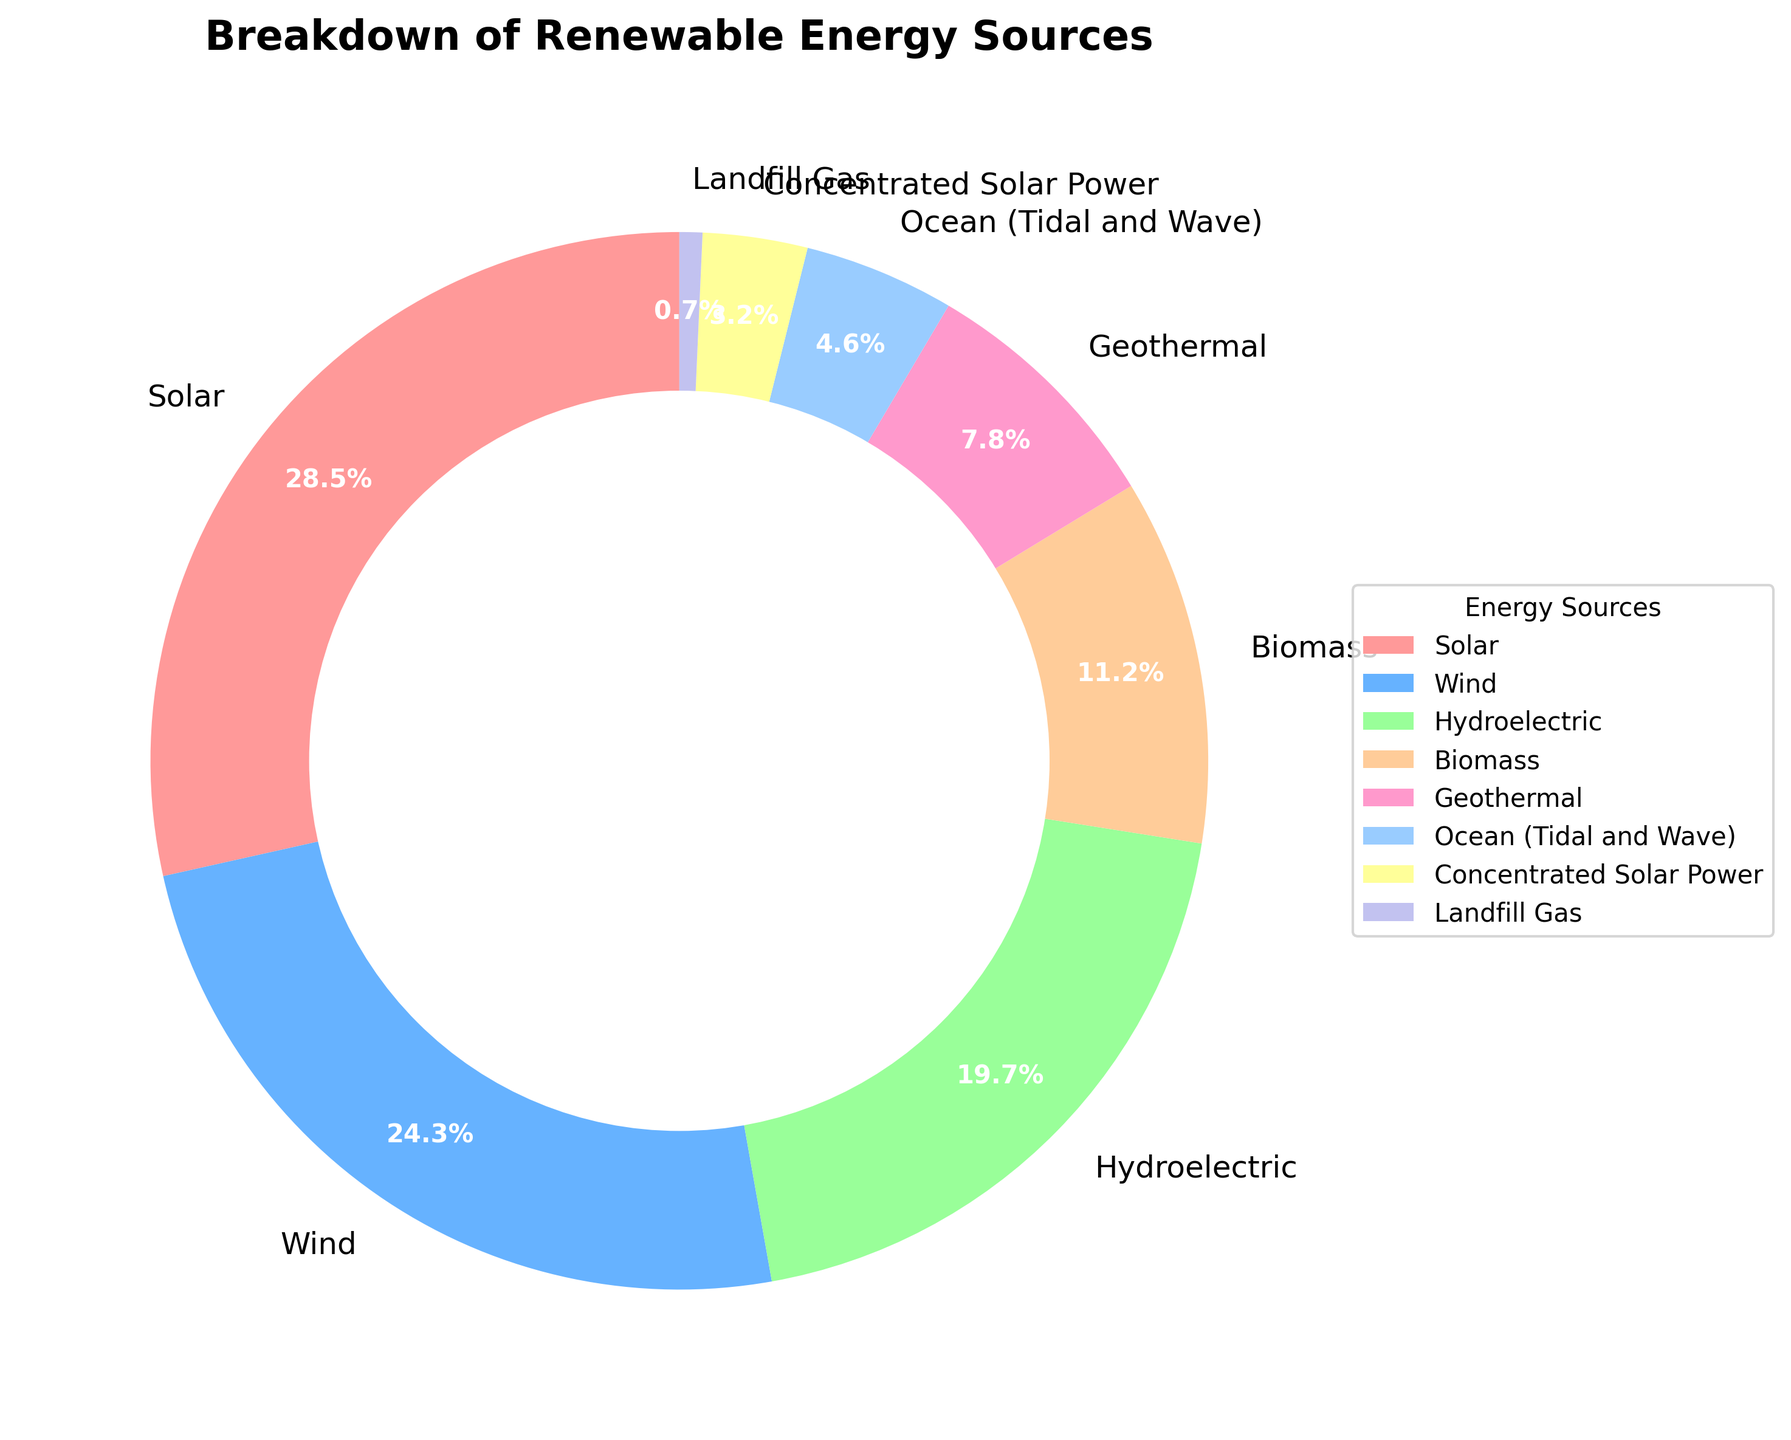Which energy source constitutes the largest portion of renewable energy production? The largest portion is identified by the section on the pie chart with the highest percentage value. Solar energy is marked with 28.5%, which is the highest.
Answer: Solar What is the combined percentage of wind, hydroelectric, and biomass energy sources? Adding the percentages for wind (24.3%), hydroelectric (19.7%), and biomass (11.2%) gives us 24.3 + 19.7 + 11.2 = 55.2%.
Answer: 55.2% Is the percentage of geothermal energy greater than the combined percentage of ocean (tidal and wave) and landfill gas? The percentage of geothermal energy is 7.8%. The combined percentage of ocean (4.6%) and landfill gas (0.7%) is 4.6 + 0.7 = 5.3%. Since 7.8% > 5.3%, geothermal is greater.
Answer: Yes Which energy source has the smallest contribution to the total energy production? The smallest portion is identified by the section on the pie chart with the lowest percentage value. Landfill Gas is marked with 0.7%, which is the smallest.
Answer: Landfill Gas What is the difference in percentage between solar and wind energy production? The difference is calculated as subtracting the percentage of wind energy from the percentage of solar energy: 28.5% - 24.3% = 4.2%.
Answer: 4.2% What color is used to represent hydroelectric energy in the pie chart? According to the custom color palette and the order of the data, hydroelectric energy (19.7%) is represented by the fourth color: '#FFCC99', which usually appears as a peach or tan color.
Answer: Peach/Tan Which energy sources together make up less than 10% of the total energy production? By identifying the segments smaller than 10% on the pie chart: Concentrated Solar Power (3.2%) and Landfill Gas (0.7%) combine for a total of 3.2 + 0.7 = 3.9%. There are no other sources less than 10%.
Answer: Concentrated Solar Power, Landfill Gas What is the average percentage of the 'Wind' and 'Hydroelectric' energy sources? Adding the percentages for wind (24.3%) and hydroelectric (19.7%) and then dividing by 2: (24.3 + 19.7) / 2 = 22%.
Answer: 22% Is biomass energy less than half the percentage of solar energy? The percentage of biomass energy is 11.2%. Half the percentage of solar energy is 28.5% / 2 = 14.25%. Since 11.2% < 14.25%, biomass energy is less than half of solar energy.
Answer: Yes What is the total percentage of renewable energy sources excluding solar and wind energy? Subtracting the combined percentage of solar (28.5%) and wind (24.3%) from 100%: 100% - (28.5 + 24.3) = 47.2%.
Answer: 47.2% 